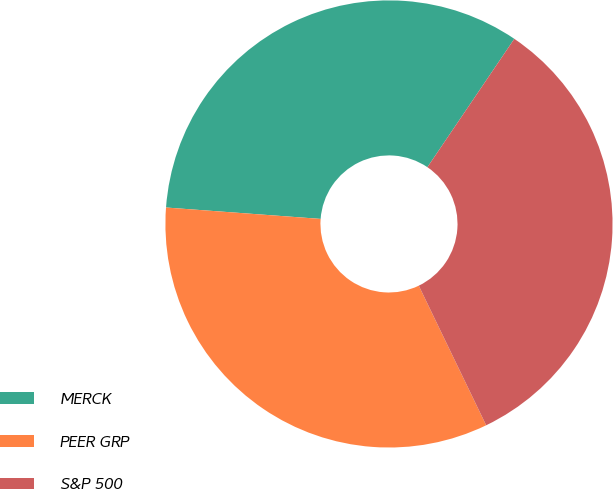Convert chart. <chart><loc_0><loc_0><loc_500><loc_500><pie_chart><fcel>MERCK<fcel>PEER GRP<fcel>S&P 500<nl><fcel>33.3%<fcel>33.33%<fcel>33.37%<nl></chart> 